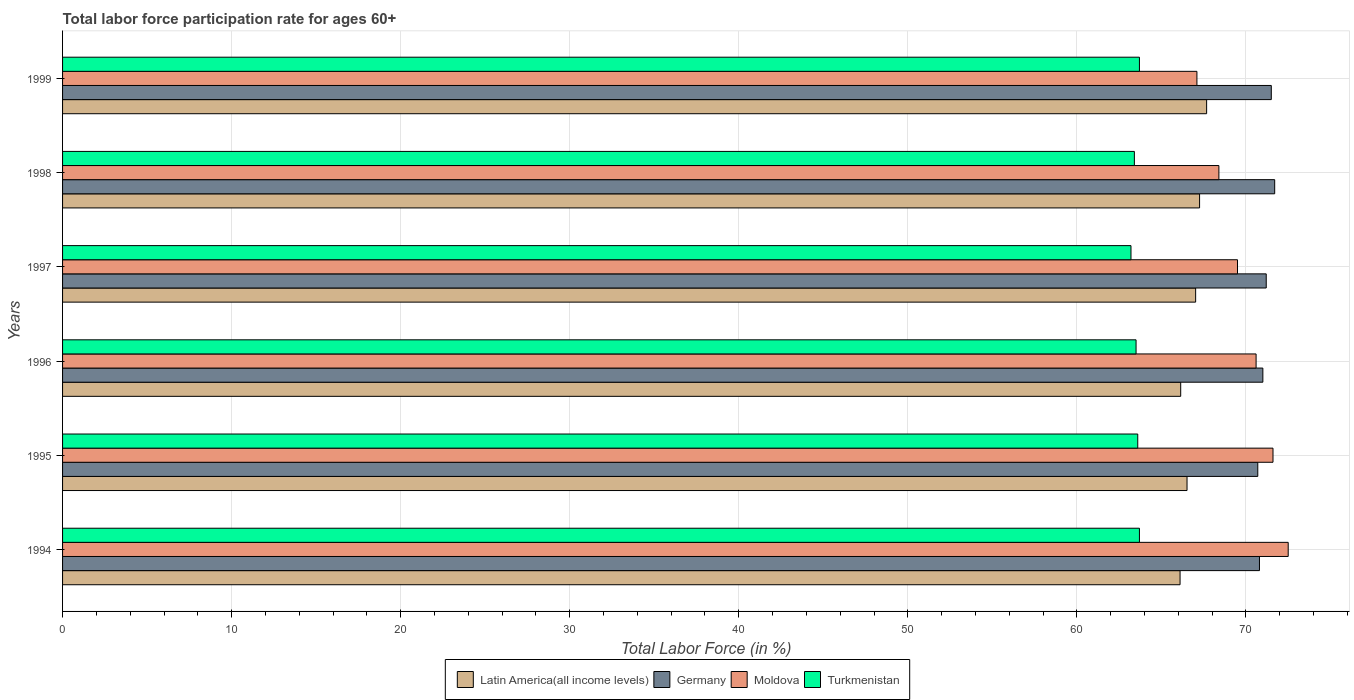How many groups of bars are there?
Offer a very short reply. 6. Are the number of bars on each tick of the Y-axis equal?
Ensure brevity in your answer.  Yes. How many bars are there on the 1st tick from the bottom?
Your answer should be compact. 4. What is the labor force participation rate in Germany in 1994?
Your answer should be very brief. 70.8. Across all years, what is the maximum labor force participation rate in Turkmenistan?
Offer a terse response. 63.7. Across all years, what is the minimum labor force participation rate in Turkmenistan?
Your response must be concise. 63.2. In which year was the labor force participation rate in Turkmenistan minimum?
Keep it short and to the point. 1997. What is the total labor force participation rate in Latin America(all income levels) in the graph?
Your answer should be compact. 400.71. What is the difference between the labor force participation rate in Latin America(all income levels) in 1995 and that in 1997?
Make the answer very short. -0.51. What is the difference between the labor force participation rate in Latin America(all income levels) in 1994 and the labor force participation rate in Germany in 1995?
Your answer should be compact. -4.6. What is the average labor force participation rate in Germany per year?
Offer a terse response. 71.15. In the year 1995, what is the difference between the labor force participation rate in Germany and labor force participation rate in Moldova?
Offer a very short reply. -0.9. In how many years, is the labor force participation rate in Turkmenistan greater than 38 %?
Give a very brief answer. 6. What is the ratio of the labor force participation rate in Germany in 1994 to that in 1995?
Your answer should be compact. 1. What is the difference between the highest and the second highest labor force participation rate in Latin America(all income levels)?
Provide a succinct answer. 0.42. What is the difference between the highest and the lowest labor force participation rate in Latin America(all income levels)?
Your answer should be compact. 1.57. In how many years, is the labor force participation rate in Latin America(all income levels) greater than the average labor force participation rate in Latin America(all income levels) taken over all years?
Your response must be concise. 3. Is the sum of the labor force participation rate in Germany in 1997 and 1998 greater than the maximum labor force participation rate in Latin America(all income levels) across all years?
Your answer should be very brief. Yes. What does the 4th bar from the top in 1994 represents?
Offer a terse response. Latin America(all income levels). Is it the case that in every year, the sum of the labor force participation rate in Moldova and labor force participation rate in Latin America(all income levels) is greater than the labor force participation rate in Turkmenistan?
Offer a terse response. Yes. How many bars are there?
Your answer should be very brief. 24. How many years are there in the graph?
Offer a terse response. 6. Does the graph contain any zero values?
Make the answer very short. No. Does the graph contain grids?
Make the answer very short. Yes. Where does the legend appear in the graph?
Your response must be concise. Bottom center. How are the legend labels stacked?
Your answer should be very brief. Horizontal. What is the title of the graph?
Keep it short and to the point. Total labor force participation rate for ages 60+. Does "Estonia" appear as one of the legend labels in the graph?
Provide a short and direct response. No. What is the label or title of the X-axis?
Give a very brief answer. Total Labor Force (in %). What is the Total Labor Force (in %) of Latin America(all income levels) in 1994?
Your answer should be very brief. 66.1. What is the Total Labor Force (in %) of Germany in 1994?
Offer a terse response. 70.8. What is the Total Labor Force (in %) in Moldova in 1994?
Keep it short and to the point. 72.5. What is the Total Labor Force (in %) of Turkmenistan in 1994?
Your response must be concise. 63.7. What is the Total Labor Force (in %) of Latin America(all income levels) in 1995?
Make the answer very short. 66.52. What is the Total Labor Force (in %) in Germany in 1995?
Make the answer very short. 70.7. What is the Total Labor Force (in %) of Moldova in 1995?
Provide a succinct answer. 71.6. What is the Total Labor Force (in %) of Turkmenistan in 1995?
Provide a succinct answer. 63.6. What is the Total Labor Force (in %) in Latin America(all income levels) in 1996?
Give a very brief answer. 66.14. What is the Total Labor Force (in %) of Moldova in 1996?
Ensure brevity in your answer.  70.6. What is the Total Labor Force (in %) of Turkmenistan in 1996?
Keep it short and to the point. 63.5. What is the Total Labor Force (in %) of Latin America(all income levels) in 1997?
Your answer should be very brief. 67.02. What is the Total Labor Force (in %) in Germany in 1997?
Provide a succinct answer. 71.2. What is the Total Labor Force (in %) of Moldova in 1997?
Provide a short and direct response. 69.5. What is the Total Labor Force (in %) of Turkmenistan in 1997?
Make the answer very short. 63.2. What is the Total Labor Force (in %) in Latin America(all income levels) in 1998?
Provide a succinct answer. 67.26. What is the Total Labor Force (in %) in Germany in 1998?
Make the answer very short. 71.7. What is the Total Labor Force (in %) of Moldova in 1998?
Provide a short and direct response. 68.4. What is the Total Labor Force (in %) of Turkmenistan in 1998?
Ensure brevity in your answer.  63.4. What is the Total Labor Force (in %) in Latin America(all income levels) in 1999?
Your answer should be compact. 67.67. What is the Total Labor Force (in %) in Germany in 1999?
Offer a very short reply. 71.5. What is the Total Labor Force (in %) in Moldova in 1999?
Ensure brevity in your answer.  67.1. What is the Total Labor Force (in %) in Turkmenistan in 1999?
Your answer should be compact. 63.7. Across all years, what is the maximum Total Labor Force (in %) in Latin America(all income levels)?
Offer a very short reply. 67.67. Across all years, what is the maximum Total Labor Force (in %) in Germany?
Offer a very short reply. 71.7. Across all years, what is the maximum Total Labor Force (in %) of Moldova?
Ensure brevity in your answer.  72.5. Across all years, what is the maximum Total Labor Force (in %) in Turkmenistan?
Provide a succinct answer. 63.7. Across all years, what is the minimum Total Labor Force (in %) of Latin America(all income levels)?
Keep it short and to the point. 66.1. Across all years, what is the minimum Total Labor Force (in %) of Germany?
Your answer should be very brief. 70.7. Across all years, what is the minimum Total Labor Force (in %) in Moldova?
Your answer should be compact. 67.1. Across all years, what is the minimum Total Labor Force (in %) of Turkmenistan?
Your response must be concise. 63.2. What is the total Total Labor Force (in %) of Latin America(all income levels) in the graph?
Ensure brevity in your answer.  400.71. What is the total Total Labor Force (in %) in Germany in the graph?
Ensure brevity in your answer.  426.9. What is the total Total Labor Force (in %) of Moldova in the graph?
Keep it short and to the point. 419.7. What is the total Total Labor Force (in %) in Turkmenistan in the graph?
Provide a succinct answer. 381.1. What is the difference between the Total Labor Force (in %) of Latin America(all income levels) in 1994 and that in 1995?
Keep it short and to the point. -0.41. What is the difference between the Total Labor Force (in %) of Germany in 1994 and that in 1995?
Your answer should be very brief. 0.1. What is the difference between the Total Labor Force (in %) of Moldova in 1994 and that in 1995?
Offer a very short reply. 0.9. What is the difference between the Total Labor Force (in %) in Turkmenistan in 1994 and that in 1995?
Your answer should be compact. 0.1. What is the difference between the Total Labor Force (in %) of Latin America(all income levels) in 1994 and that in 1996?
Provide a succinct answer. -0.04. What is the difference between the Total Labor Force (in %) in Latin America(all income levels) in 1994 and that in 1997?
Your answer should be very brief. -0.92. What is the difference between the Total Labor Force (in %) in Moldova in 1994 and that in 1997?
Keep it short and to the point. 3. What is the difference between the Total Labor Force (in %) of Turkmenistan in 1994 and that in 1997?
Offer a terse response. 0.5. What is the difference between the Total Labor Force (in %) of Latin America(all income levels) in 1994 and that in 1998?
Your answer should be compact. -1.15. What is the difference between the Total Labor Force (in %) in Germany in 1994 and that in 1998?
Your answer should be very brief. -0.9. What is the difference between the Total Labor Force (in %) of Latin America(all income levels) in 1994 and that in 1999?
Your response must be concise. -1.57. What is the difference between the Total Labor Force (in %) of Germany in 1994 and that in 1999?
Provide a short and direct response. -0.7. What is the difference between the Total Labor Force (in %) in Turkmenistan in 1994 and that in 1999?
Make the answer very short. 0. What is the difference between the Total Labor Force (in %) in Latin America(all income levels) in 1995 and that in 1996?
Keep it short and to the point. 0.37. What is the difference between the Total Labor Force (in %) of Germany in 1995 and that in 1996?
Make the answer very short. -0.3. What is the difference between the Total Labor Force (in %) in Moldova in 1995 and that in 1996?
Give a very brief answer. 1. What is the difference between the Total Labor Force (in %) of Turkmenistan in 1995 and that in 1996?
Your response must be concise. 0.1. What is the difference between the Total Labor Force (in %) of Latin America(all income levels) in 1995 and that in 1997?
Ensure brevity in your answer.  -0.51. What is the difference between the Total Labor Force (in %) of Moldova in 1995 and that in 1997?
Your response must be concise. 2.1. What is the difference between the Total Labor Force (in %) in Turkmenistan in 1995 and that in 1997?
Offer a terse response. 0.4. What is the difference between the Total Labor Force (in %) of Latin America(all income levels) in 1995 and that in 1998?
Give a very brief answer. -0.74. What is the difference between the Total Labor Force (in %) of Moldova in 1995 and that in 1998?
Your answer should be very brief. 3.2. What is the difference between the Total Labor Force (in %) of Latin America(all income levels) in 1995 and that in 1999?
Your answer should be very brief. -1.16. What is the difference between the Total Labor Force (in %) of Germany in 1995 and that in 1999?
Your answer should be compact. -0.8. What is the difference between the Total Labor Force (in %) in Latin America(all income levels) in 1996 and that in 1997?
Provide a short and direct response. -0.88. What is the difference between the Total Labor Force (in %) of Germany in 1996 and that in 1997?
Your response must be concise. -0.2. What is the difference between the Total Labor Force (in %) in Turkmenistan in 1996 and that in 1997?
Keep it short and to the point. 0.3. What is the difference between the Total Labor Force (in %) in Latin America(all income levels) in 1996 and that in 1998?
Your response must be concise. -1.12. What is the difference between the Total Labor Force (in %) in Latin America(all income levels) in 1996 and that in 1999?
Your answer should be compact. -1.53. What is the difference between the Total Labor Force (in %) in Moldova in 1996 and that in 1999?
Make the answer very short. 3.5. What is the difference between the Total Labor Force (in %) in Latin America(all income levels) in 1997 and that in 1998?
Make the answer very short. -0.23. What is the difference between the Total Labor Force (in %) of Moldova in 1997 and that in 1998?
Offer a terse response. 1.1. What is the difference between the Total Labor Force (in %) of Turkmenistan in 1997 and that in 1998?
Keep it short and to the point. -0.2. What is the difference between the Total Labor Force (in %) of Latin America(all income levels) in 1997 and that in 1999?
Your answer should be very brief. -0.65. What is the difference between the Total Labor Force (in %) in Moldova in 1997 and that in 1999?
Provide a short and direct response. 2.4. What is the difference between the Total Labor Force (in %) in Latin America(all income levels) in 1998 and that in 1999?
Provide a short and direct response. -0.42. What is the difference between the Total Labor Force (in %) in Moldova in 1998 and that in 1999?
Provide a succinct answer. 1.3. What is the difference between the Total Labor Force (in %) of Turkmenistan in 1998 and that in 1999?
Ensure brevity in your answer.  -0.3. What is the difference between the Total Labor Force (in %) in Latin America(all income levels) in 1994 and the Total Labor Force (in %) in Germany in 1995?
Provide a short and direct response. -4.6. What is the difference between the Total Labor Force (in %) in Latin America(all income levels) in 1994 and the Total Labor Force (in %) in Moldova in 1995?
Your answer should be compact. -5.5. What is the difference between the Total Labor Force (in %) in Latin America(all income levels) in 1994 and the Total Labor Force (in %) in Turkmenistan in 1995?
Ensure brevity in your answer.  2.5. What is the difference between the Total Labor Force (in %) in Germany in 1994 and the Total Labor Force (in %) in Moldova in 1995?
Offer a very short reply. -0.8. What is the difference between the Total Labor Force (in %) in Germany in 1994 and the Total Labor Force (in %) in Turkmenistan in 1995?
Provide a succinct answer. 7.2. What is the difference between the Total Labor Force (in %) in Latin America(all income levels) in 1994 and the Total Labor Force (in %) in Germany in 1996?
Ensure brevity in your answer.  -4.9. What is the difference between the Total Labor Force (in %) in Latin America(all income levels) in 1994 and the Total Labor Force (in %) in Moldova in 1996?
Give a very brief answer. -4.5. What is the difference between the Total Labor Force (in %) of Latin America(all income levels) in 1994 and the Total Labor Force (in %) of Turkmenistan in 1996?
Give a very brief answer. 2.6. What is the difference between the Total Labor Force (in %) of Germany in 1994 and the Total Labor Force (in %) of Moldova in 1996?
Your answer should be compact. 0.2. What is the difference between the Total Labor Force (in %) in Moldova in 1994 and the Total Labor Force (in %) in Turkmenistan in 1996?
Provide a short and direct response. 9. What is the difference between the Total Labor Force (in %) in Latin America(all income levels) in 1994 and the Total Labor Force (in %) in Germany in 1997?
Provide a short and direct response. -5.1. What is the difference between the Total Labor Force (in %) of Latin America(all income levels) in 1994 and the Total Labor Force (in %) of Moldova in 1997?
Keep it short and to the point. -3.4. What is the difference between the Total Labor Force (in %) in Latin America(all income levels) in 1994 and the Total Labor Force (in %) in Turkmenistan in 1997?
Ensure brevity in your answer.  2.9. What is the difference between the Total Labor Force (in %) in Latin America(all income levels) in 1994 and the Total Labor Force (in %) in Germany in 1998?
Give a very brief answer. -5.6. What is the difference between the Total Labor Force (in %) of Latin America(all income levels) in 1994 and the Total Labor Force (in %) of Moldova in 1998?
Provide a succinct answer. -2.3. What is the difference between the Total Labor Force (in %) of Latin America(all income levels) in 1994 and the Total Labor Force (in %) of Turkmenistan in 1998?
Offer a terse response. 2.7. What is the difference between the Total Labor Force (in %) of Germany in 1994 and the Total Labor Force (in %) of Moldova in 1998?
Your answer should be compact. 2.4. What is the difference between the Total Labor Force (in %) in Latin America(all income levels) in 1994 and the Total Labor Force (in %) in Germany in 1999?
Your answer should be compact. -5.4. What is the difference between the Total Labor Force (in %) of Latin America(all income levels) in 1994 and the Total Labor Force (in %) of Moldova in 1999?
Provide a succinct answer. -1. What is the difference between the Total Labor Force (in %) in Latin America(all income levels) in 1994 and the Total Labor Force (in %) in Turkmenistan in 1999?
Provide a succinct answer. 2.4. What is the difference between the Total Labor Force (in %) of Moldova in 1994 and the Total Labor Force (in %) of Turkmenistan in 1999?
Keep it short and to the point. 8.8. What is the difference between the Total Labor Force (in %) in Latin America(all income levels) in 1995 and the Total Labor Force (in %) in Germany in 1996?
Your response must be concise. -4.48. What is the difference between the Total Labor Force (in %) in Latin America(all income levels) in 1995 and the Total Labor Force (in %) in Moldova in 1996?
Your answer should be very brief. -4.08. What is the difference between the Total Labor Force (in %) in Latin America(all income levels) in 1995 and the Total Labor Force (in %) in Turkmenistan in 1996?
Your response must be concise. 3.02. What is the difference between the Total Labor Force (in %) of Germany in 1995 and the Total Labor Force (in %) of Moldova in 1996?
Keep it short and to the point. 0.1. What is the difference between the Total Labor Force (in %) in Latin America(all income levels) in 1995 and the Total Labor Force (in %) in Germany in 1997?
Your response must be concise. -4.68. What is the difference between the Total Labor Force (in %) of Latin America(all income levels) in 1995 and the Total Labor Force (in %) of Moldova in 1997?
Provide a short and direct response. -2.98. What is the difference between the Total Labor Force (in %) in Latin America(all income levels) in 1995 and the Total Labor Force (in %) in Turkmenistan in 1997?
Offer a terse response. 3.32. What is the difference between the Total Labor Force (in %) of Latin America(all income levels) in 1995 and the Total Labor Force (in %) of Germany in 1998?
Offer a terse response. -5.18. What is the difference between the Total Labor Force (in %) in Latin America(all income levels) in 1995 and the Total Labor Force (in %) in Moldova in 1998?
Offer a terse response. -1.88. What is the difference between the Total Labor Force (in %) in Latin America(all income levels) in 1995 and the Total Labor Force (in %) in Turkmenistan in 1998?
Offer a very short reply. 3.12. What is the difference between the Total Labor Force (in %) of Moldova in 1995 and the Total Labor Force (in %) of Turkmenistan in 1998?
Give a very brief answer. 8.2. What is the difference between the Total Labor Force (in %) in Latin America(all income levels) in 1995 and the Total Labor Force (in %) in Germany in 1999?
Your response must be concise. -4.98. What is the difference between the Total Labor Force (in %) of Latin America(all income levels) in 1995 and the Total Labor Force (in %) of Moldova in 1999?
Give a very brief answer. -0.58. What is the difference between the Total Labor Force (in %) of Latin America(all income levels) in 1995 and the Total Labor Force (in %) of Turkmenistan in 1999?
Your response must be concise. 2.82. What is the difference between the Total Labor Force (in %) of Germany in 1995 and the Total Labor Force (in %) of Turkmenistan in 1999?
Provide a succinct answer. 7. What is the difference between the Total Labor Force (in %) of Moldova in 1995 and the Total Labor Force (in %) of Turkmenistan in 1999?
Your answer should be compact. 7.9. What is the difference between the Total Labor Force (in %) of Latin America(all income levels) in 1996 and the Total Labor Force (in %) of Germany in 1997?
Keep it short and to the point. -5.06. What is the difference between the Total Labor Force (in %) of Latin America(all income levels) in 1996 and the Total Labor Force (in %) of Moldova in 1997?
Provide a short and direct response. -3.36. What is the difference between the Total Labor Force (in %) of Latin America(all income levels) in 1996 and the Total Labor Force (in %) of Turkmenistan in 1997?
Provide a short and direct response. 2.94. What is the difference between the Total Labor Force (in %) in Germany in 1996 and the Total Labor Force (in %) in Moldova in 1997?
Offer a terse response. 1.5. What is the difference between the Total Labor Force (in %) of Germany in 1996 and the Total Labor Force (in %) of Turkmenistan in 1997?
Your answer should be very brief. 7.8. What is the difference between the Total Labor Force (in %) in Moldova in 1996 and the Total Labor Force (in %) in Turkmenistan in 1997?
Offer a terse response. 7.4. What is the difference between the Total Labor Force (in %) in Latin America(all income levels) in 1996 and the Total Labor Force (in %) in Germany in 1998?
Offer a terse response. -5.56. What is the difference between the Total Labor Force (in %) of Latin America(all income levels) in 1996 and the Total Labor Force (in %) of Moldova in 1998?
Give a very brief answer. -2.26. What is the difference between the Total Labor Force (in %) of Latin America(all income levels) in 1996 and the Total Labor Force (in %) of Turkmenistan in 1998?
Give a very brief answer. 2.74. What is the difference between the Total Labor Force (in %) in Germany in 1996 and the Total Labor Force (in %) in Turkmenistan in 1998?
Keep it short and to the point. 7.6. What is the difference between the Total Labor Force (in %) in Latin America(all income levels) in 1996 and the Total Labor Force (in %) in Germany in 1999?
Provide a succinct answer. -5.36. What is the difference between the Total Labor Force (in %) of Latin America(all income levels) in 1996 and the Total Labor Force (in %) of Moldova in 1999?
Provide a short and direct response. -0.96. What is the difference between the Total Labor Force (in %) of Latin America(all income levels) in 1996 and the Total Labor Force (in %) of Turkmenistan in 1999?
Provide a succinct answer. 2.44. What is the difference between the Total Labor Force (in %) in Germany in 1996 and the Total Labor Force (in %) in Moldova in 1999?
Provide a succinct answer. 3.9. What is the difference between the Total Labor Force (in %) of Germany in 1996 and the Total Labor Force (in %) of Turkmenistan in 1999?
Your response must be concise. 7.3. What is the difference between the Total Labor Force (in %) in Moldova in 1996 and the Total Labor Force (in %) in Turkmenistan in 1999?
Keep it short and to the point. 6.9. What is the difference between the Total Labor Force (in %) in Latin America(all income levels) in 1997 and the Total Labor Force (in %) in Germany in 1998?
Provide a succinct answer. -4.68. What is the difference between the Total Labor Force (in %) of Latin America(all income levels) in 1997 and the Total Labor Force (in %) of Moldova in 1998?
Give a very brief answer. -1.38. What is the difference between the Total Labor Force (in %) of Latin America(all income levels) in 1997 and the Total Labor Force (in %) of Turkmenistan in 1998?
Give a very brief answer. 3.62. What is the difference between the Total Labor Force (in %) in Latin America(all income levels) in 1997 and the Total Labor Force (in %) in Germany in 1999?
Your response must be concise. -4.48. What is the difference between the Total Labor Force (in %) of Latin America(all income levels) in 1997 and the Total Labor Force (in %) of Moldova in 1999?
Your response must be concise. -0.08. What is the difference between the Total Labor Force (in %) in Latin America(all income levels) in 1997 and the Total Labor Force (in %) in Turkmenistan in 1999?
Provide a succinct answer. 3.32. What is the difference between the Total Labor Force (in %) of Germany in 1997 and the Total Labor Force (in %) of Turkmenistan in 1999?
Give a very brief answer. 7.5. What is the difference between the Total Labor Force (in %) in Latin America(all income levels) in 1998 and the Total Labor Force (in %) in Germany in 1999?
Your answer should be compact. -4.24. What is the difference between the Total Labor Force (in %) in Latin America(all income levels) in 1998 and the Total Labor Force (in %) in Moldova in 1999?
Offer a terse response. 0.16. What is the difference between the Total Labor Force (in %) of Latin America(all income levels) in 1998 and the Total Labor Force (in %) of Turkmenistan in 1999?
Offer a very short reply. 3.56. What is the difference between the Total Labor Force (in %) of Germany in 1998 and the Total Labor Force (in %) of Turkmenistan in 1999?
Your response must be concise. 8. What is the difference between the Total Labor Force (in %) in Moldova in 1998 and the Total Labor Force (in %) in Turkmenistan in 1999?
Offer a very short reply. 4.7. What is the average Total Labor Force (in %) in Latin America(all income levels) per year?
Provide a short and direct response. 66.79. What is the average Total Labor Force (in %) of Germany per year?
Give a very brief answer. 71.15. What is the average Total Labor Force (in %) in Moldova per year?
Your answer should be very brief. 69.95. What is the average Total Labor Force (in %) in Turkmenistan per year?
Make the answer very short. 63.52. In the year 1994, what is the difference between the Total Labor Force (in %) of Latin America(all income levels) and Total Labor Force (in %) of Germany?
Your response must be concise. -4.7. In the year 1994, what is the difference between the Total Labor Force (in %) of Latin America(all income levels) and Total Labor Force (in %) of Moldova?
Make the answer very short. -6.4. In the year 1994, what is the difference between the Total Labor Force (in %) of Latin America(all income levels) and Total Labor Force (in %) of Turkmenistan?
Ensure brevity in your answer.  2.4. In the year 1994, what is the difference between the Total Labor Force (in %) of Moldova and Total Labor Force (in %) of Turkmenistan?
Your answer should be compact. 8.8. In the year 1995, what is the difference between the Total Labor Force (in %) in Latin America(all income levels) and Total Labor Force (in %) in Germany?
Give a very brief answer. -4.18. In the year 1995, what is the difference between the Total Labor Force (in %) of Latin America(all income levels) and Total Labor Force (in %) of Moldova?
Make the answer very short. -5.08. In the year 1995, what is the difference between the Total Labor Force (in %) in Latin America(all income levels) and Total Labor Force (in %) in Turkmenistan?
Your response must be concise. 2.92. In the year 1995, what is the difference between the Total Labor Force (in %) in Moldova and Total Labor Force (in %) in Turkmenistan?
Your answer should be compact. 8. In the year 1996, what is the difference between the Total Labor Force (in %) in Latin America(all income levels) and Total Labor Force (in %) in Germany?
Offer a very short reply. -4.86. In the year 1996, what is the difference between the Total Labor Force (in %) in Latin America(all income levels) and Total Labor Force (in %) in Moldova?
Offer a very short reply. -4.46. In the year 1996, what is the difference between the Total Labor Force (in %) of Latin America(all income levels) and Total Labor Force (in %) of Turkmenistan?
Ensure brevity in your answer.  2.64. In the year 1996, what is the difference between the Total Labor Force (in %) of Moldova and Total Labor Force (in %) of Turkmenistan?
Make the answer very short. 7.1. In the year 1997, what is the difference between the Total Labor Force (in %) of Latin America(all income levels) and Total Labor Force (in %) of Germany?
Offer a terse response. -4.18. In the year 1997, what is the difference between the Total Labor Force (in %) of Latin America(all income levels) and Total Labor Force (in %) of Moldova?
Ensure brevity in your answer.  -2.48. In the year 1997, what is the difference between the Total Labor Force (in %) of Latin America(all income levels) and Total Labor Force (in %) of Turkmenistan?
Your response must be concise. 3.82. In the year 1997, what is the difference between the Total Labor Force (in %) in Germany and Total Labor Force (in %) in Turkmenistan?
Keep it short and to the point. 8. In the year 1997, what is the difference between the Total Labor Force (in %) in Moldova and Total Labor Force (in %) in Turkmenistan?
Make the answer very short. 6.3. In the year 1998, what is the difference between the Total Labor Force (in %) in Latin America(all income levels) and Total Labor Force (in %) in Germany?
Your response must be concise. -4.44. In the year 1998, what is the difference between the Total Labor Force (in %) of Latin America(all income levels) and Total Labor Force (in %) of Moldova?
Keep it short and to the point. -1.14. In the year 1998, what is the difference between the Total Labor Force (in %) in Latin America(all income levels) and Total Labor Force (in %) in Turkmenistan?
Make the answer very short. 3.86. In the year 1998, what is the difference between the Total Labor Force (in %) in Germany and Total Labor Force (in %) in Moldova?
Provide a short and direct response. 3.3. In the year 1999, what is the difference between the Total Labor Force (in %) of Latin America(all income levels) and Total Labor Force (in %) of Germany?
Provide a succinct answer. -3.83. In the year 1999, what is the difference between the Total Labor Force (in %) in Latin America(all income levels) and Total Labor Force (in %) in Moldova?
Provide a short and direct response. 0.57. In the year 1999, what is the difference between the Total Labor Force (in %) in Latin America(all income levels) and Total Labor Force (in %) in Turkmenistan?
Offer a very short reply. 3.97. In the year 1999, what is the difference between the Total Labor Force (in %) in Germany and Total Labor Force (in %) in Moldova?
Your response must be concise. 4.4. In the year 1999, what is the difference between the Total Labor Force (in %) of Germany and Total Labor Force (in %) of Turkmenistan?
Your response must be concise. 7.8. In the year 1999, what is the difference between the Total Labor Force (in %) of Moldova and Total Labor Force (in %) of Turkmenistan?
Your response must be concise. 3.4. What is the ratio of the Total Labor Force (in %) of Latin America(all income levels) in 1994 to that in 1995?
Ensure brevity in your answer.  0.99. What is the ratio of the Total Labor Force (in %) in Moldova in 1994 to that in 1995?
Make the answer very short. 1.01. What is the ratio of the Total Labor Force (in %) of Latin America(all income levels) in 1994 to that in 1996?
Offer a very short reply. 1. What is the ratio of the Total Labor Force (in %) of Germany in 1994 to that in 1996?
Provide a short and direct response. 1. What is the ratio of the Total Labor Force (in %) of Moldova in 1994 to that in 1996?
Ensure brevity in your answer.  1.03. What is the ratio of the Total Labor Force (in %) in Latin America(all income levels) in 1994 to that in 1997?
Offer a terse response. 0.99. What is the ratio of the Total Labor Force (in %) of Germany in 1994 to that in 1997?
Your answer should be very brief. 0.99. What is the ratio of the Total Labor Force (in %) of Moldova in 1994 to that in 1997?
Your answer should be very brief. 1.04. What is the ratio of the Total Labor Force (in %) in Turkmenistan in 1994 to that in 1997?
Offer a terse response. 1.01. What is the ratio of the Total Labor Force (in %) in Latin America(all income levels) in 1994 to that in 1998?
Make the answer very short. 0.98. What is the ratio of the Total Labor Force (in %) in Germany in 1994 to that in 1998?
Ensure brevity in your answer.  0.99. What is the ratio of the Total Labor Force (in %) of Moldova in 1994 to that in 1998?
Give a very brief answer. 1.06. What is the ratio of the Total Labor Force (in %) of Latin America(all income levels) in 1994 to that in 1999?
Provide a short and direct response. 0.98. What is the ratio of the Total Labor Force (in %) in Germany in 1994 to that in 1999?
Offer a terse response. 0.99. What is the ratio of the Total Labor Force (in %) of Moldova in 1994 to that in 1999?
Offer a very short reply. 1.08. What is the ratio of the Total Labor Force (in %) of Turkmenistan in 1994 to that in 1999?
Keep it short and to the point. 1. What is the ratio of the Total Labor Force (in %) in Moldova in 1995 to that in 1996?
Provide a short and direct response. 1.01. What is the ratio of the Total Labor Force (in %) of Germany in 1995 to that in 1997?
Ensure brevity in your answer.  0.99. What is the ratio of the Total Labor Force (in %) in Moldova in 1995 to that in 1997?
Make the answer very short. 1.03. What is the ratio of the Total Labor Force (in %) of Germany in 1995 to that in 1998?
Keep it short and to the point. 0.99. What is the ratio of the Total Labor Force (in %) in Moldova in 1995 to that in 1998?
Offer a terse response. 1.05. What is the ratio of the Total Labor Force (in %) in Turkmenistan in 1995 to that in 1998?
Provide a short and direct response. 1. What is the ratio of the Total Labor Force (in %) in Latin America(all income levels) in 1995 to that in 1999?
Provide a succinct answer. 0.98. What is the ratio of the Total Labor Force (in %) in Moldova in 1995 to that in 1999?
Keep it short and to the point. 1.07. What is the ratio of the Total Labor Force (in %) of Latin America(all income levels) in 1996 to that in 1997?
Give a very brief answer. 0.99. What is the ratio of the Total Labor Force (in %) in Moldova in 1996 to that in 1997?
Offer a very short reply. 1.02. What is the ratio of the Total Labor Force (in %) of Turkmenistan in 1996 to that in 1997?
Ensure brevity in your answer.  1. What is the ratio of the Total Labor Force (in %) of Latin America(all income levels) in 1996 to that in 1998?
Your answer should be very brief. 0.98. What is the ratio of the Total Labor Force (in %) in Germany in 1996 to that in 1998?
Keep it short and to the point. 0.99. What is the ratio of the Total Labor Force (in %) in Moldova in 1996 to that in 1998?
Offer a terse response. 1.03. What is the ratio of the Total Labor Force (in %) in Latin America(all income levels) in 1996 to that in 1999?
Ensure brevity in your answer.  0.98. What is the ratio of the Total Labor Force (in %) of Germany in 1996 to that in 1999?
Offer a very short reply. 0.99. What is the ratio of the Total Labor Force (in %) of Moldova in 1996 to that in 1999?
Keep it short and to the point. 1.05. What is the ratio of the Total Labor Force (in %) of Turkmenistan in 1996 to that in 1999?
Offer a terse response. 1. What is the ratio of the Total Labor Force (in %) of Germany in 1997 to that in 1998?
Offer a very short reply. 0.99. What is the ratio of the Total Labor Force (in %) in Moldova in 1997 to that in 1998?
Provide a succinct answer. 1.02. What is the ratio of the Total Labor Force (in %) in Moldova in 1997 to that in 1999?
Ensure brevity in your answer.  1.04. What is the ratio of the Total Labor Force (in %) of Latin America(all income levels) in 1998 to that in 1999?
Offer a terse response. 0.99. What is the ratio of the Total Labor Force (in %) in Moldova in 1998 to that in 1999?
Your response must be concise. 1.02. What is the difference between the highest and the second highest Total Labor Force (in %) of Latin America(all income levels)?
Your response must be concise. 0.42. What is the difference between the highest and the second highest Total Labor Force (in %) in Turkmenistan?
Give a very brief answer. 0. What is the difference between the highest and the lowest Total Labor Force (in %) in Latin America(all income levels)?
Make the answer very short. 1.57. What is the difference between the highest and the lowest Total Labor Force (in %) of Moldova?
Offer a terse response. 5.4. What is the difference between the highest and the lowest Total Labor Force (in %) in Turkmenistan?
Provide a short and direct response. 0.5. 